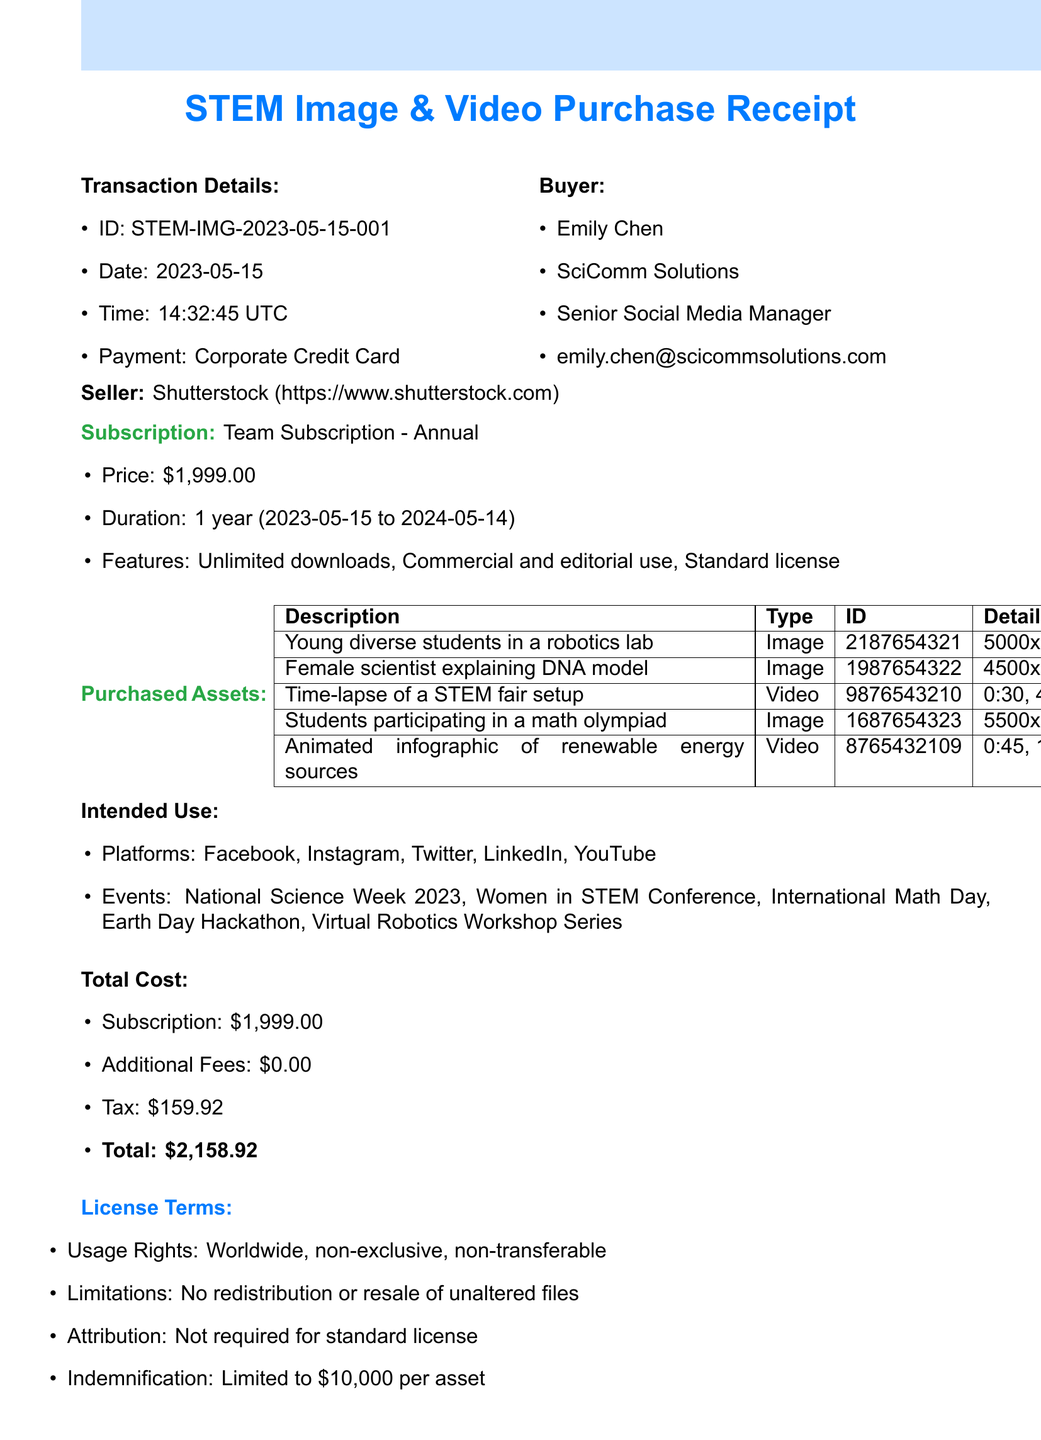what is the transaction ID? The transaction ID is listed under transaction details, which is STEM-IMG-2023-05-15-001.
Answer: STEM-IMG-2023-05-15-001 who is the buyer? The buyer name is prominently listed in the document, which is Emily Chen.
Answer: Emily Chen what is the total cost of the subscription? The total cost of the subscription is itemized in the total cost section as $1,999.00.
Answer: $1,999.00 how many platforms are listed for intended use? The intended use section mentions multiple platforms for utilization, which totals five platforms.
Answer: 5 what is the expiration date of the subscription? The expiration date is mentioned in the subscription details section, which states it is 2024-05-14.
Answer: 2024-05-14 what types of assets were purchased? The document lists the types of purchased assets, which include images and videos.
Answer: Images and Videos who is the seller company? The seller company's name is provided toward the bottom of the document as Shutterstock.
Answer: Shutterstock what is the duration of the subscription? The duration is specified in the subscription details, which indicates it is for 1 year.
Answer: 1 year is attribution required for the purchased assets? The license terms section explicitly states that attribution is not required for a standard license.
Answer: Not required 